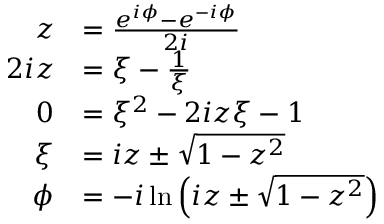<formula> <loc_0><loc_0><loc_500><loc_500>{ \begin{array} { r l } { z } & { = { \frac { e ^ { i \phi } - e ^ { - i \phi } } { 2 i } } } \\ { 2 i z } & { = \xi - { \frac { 1 } { \xi } } } \\ { 0 } & { = \xi ^ { 2 } - 2 i z \xi - 1 } \\ { \xi } & { = i z \pm { \sqrt { 1 - z ^ { 2 } } } } \\ { \phi } & { = - i \ln \left ( i z \pm { \sqrt { 1 - z ^ { 2 } } } \right ) } \end{array} }</formula> 